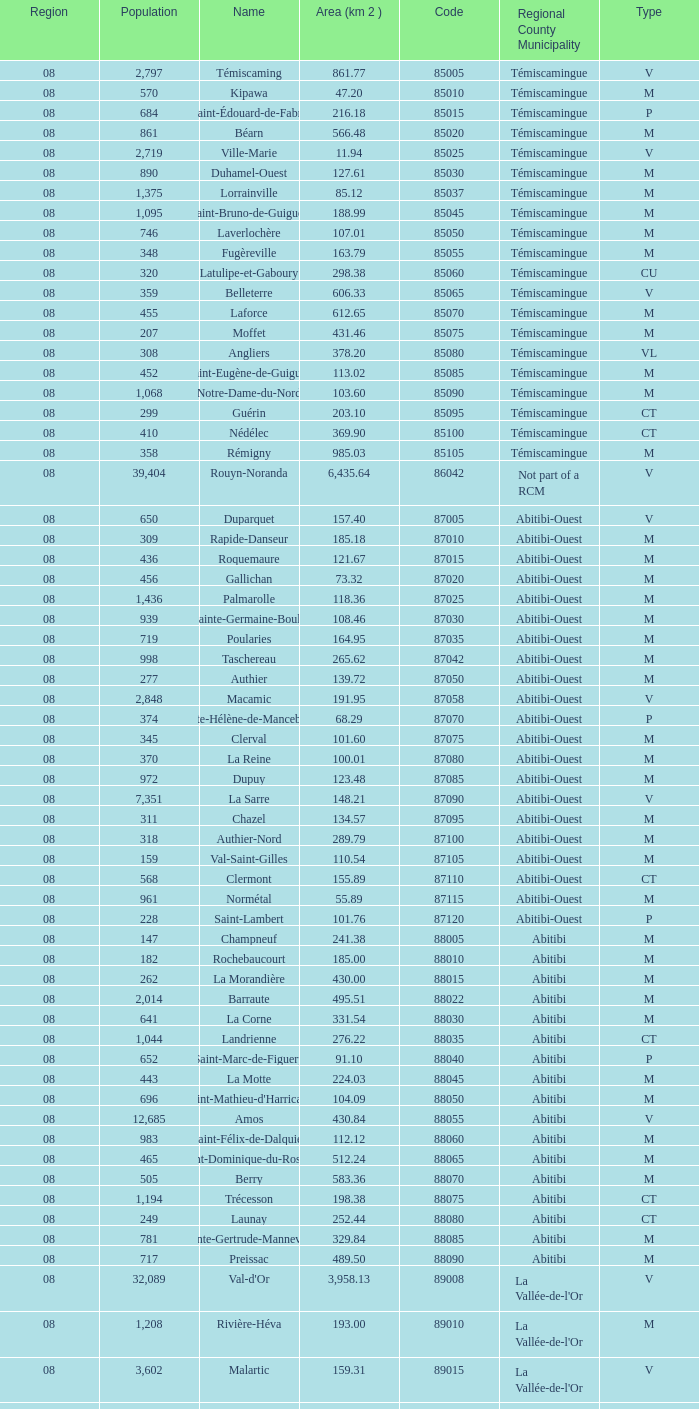What municipality has 719 people and is larger than 108.46 km2? Abitibi-Ouest. 